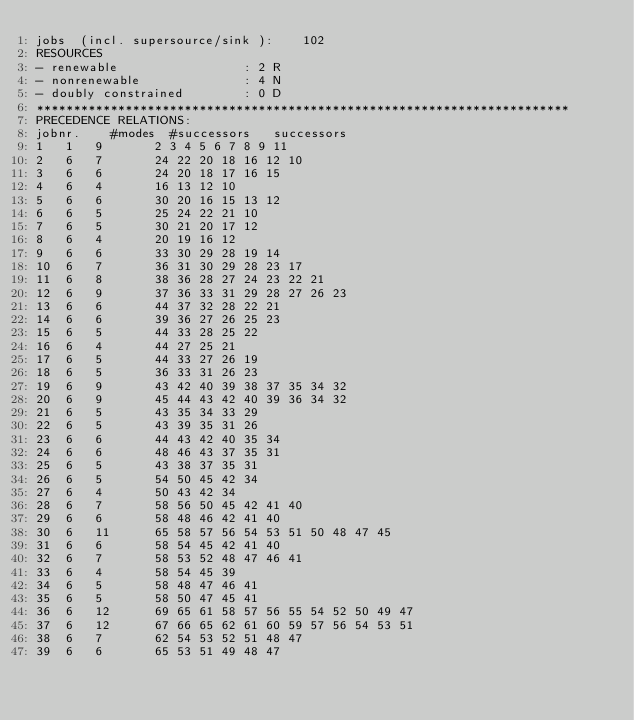<code> <loc_0><loc_0><loc_500><loc_500><_ObjectiveC_>jobs  (incl. supersource/sink ):	102
RESOURCES
- renewable                 : 2 R
- nonrenewable              : 4 N
- doubly constrained        : 0 D
************************************************************************
PRECEDENCE RELATIONS:
jobnr.    #modes  #successors   successors
1	1	9		2 3 4 5 6 7 8 9 11 
2	6	7		24 22 20 18 16 12 10 
3	6	6		24 20 18 17 16 15 
4	6	4		16 13 12 10 
5	6	6		30 20 16 15 13 12 
6	6	5		25 24 22 21 10 
7	6	5		30 21 20 17 12 
8	6	4		20 19 16 12 
9	6	6		33 30 29 28 19 14 
10	6	7		36 31 30 29 28 23 17 
11	6	8		38 36 28 27 24 23 22 21 
12	6	9		37 36 33 31 29 28 27 26 23 
13	6	6		44 37 32 28 22 21 
14	6	6		39 36 27 26 25 23 
15	6	5		44 33 28 25 22 
16	6	4		44 27 25 21 
17	6	5		44 33 27 26 19 
18	6	5		36 33 31 26 23 
19	6	9		43 42 40 39 38 37 35 34 32 
20	6	9		45 44 43 42 40 39 36 34 32 
21	6	5		43 35 34 33 29 
22	6	5		43 39 35 31 26 
23	6	6		44 43 42 40 35 34 
24	6	6		48 46 43 37 35 31 
25	6	5		43 38 37 35 31 
26	6	5		54 50 45 42 34 
27	6	4		50 43 42 34 
28	6	7		58 56 50 45 42 41 40 
29	6	6		58 48 46 42 41 40 
30	6	11		65 58 57 56 54 53 51 50 48 47 45 
31	6	6		58 54 45 42 41 40 
32	6	7		58 53 52 48 47 46 41 
33	6	4		58 54 45 39 
34	6	5		58 48 47 46 41 
35	6	5		58 50 47 45 41 
36	6	12		69 65 61 58 57 56 55 54 52 50 49 47 
37	6	12		67 66 65 62 61 60 59 57 56 54 53 51 
38	6	7		62 54 53 52 51 48 47 
39	6	6		65 53 51 49 48 47 </code> 